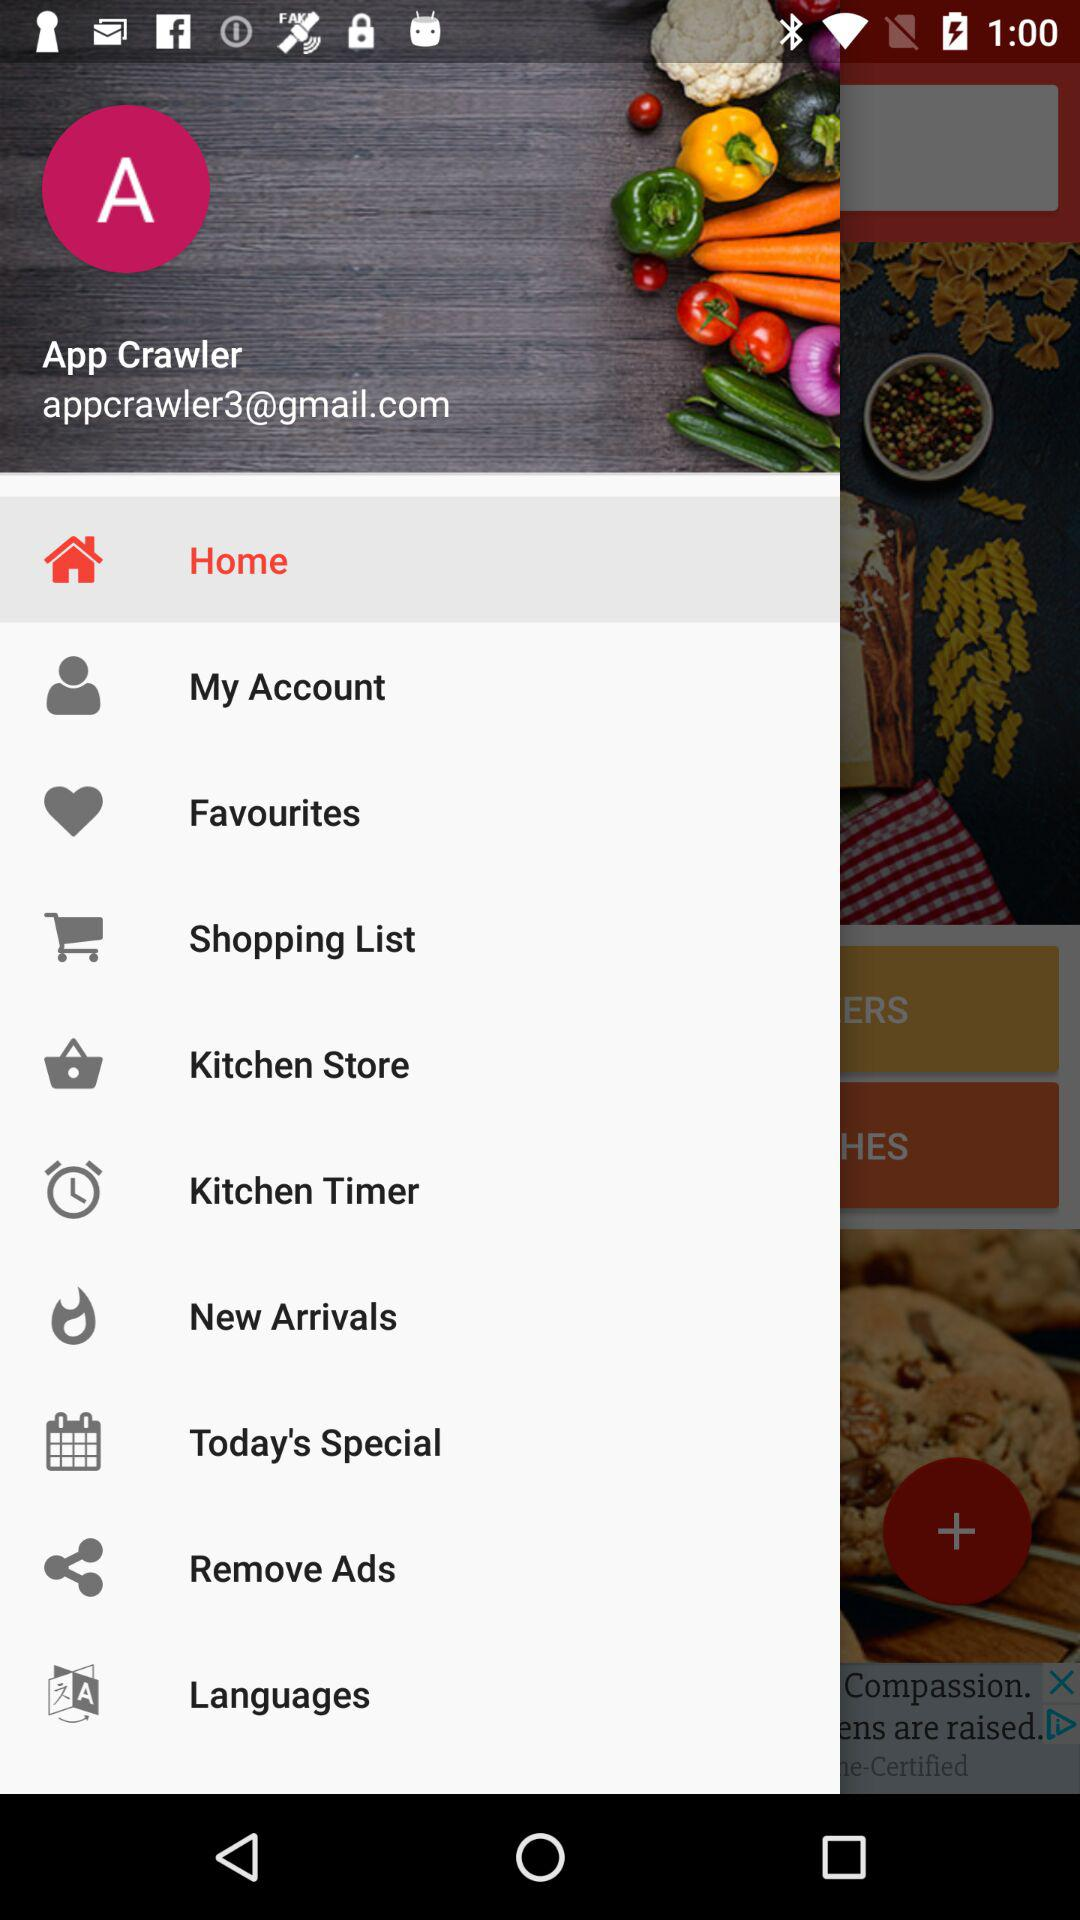What is the user name? The user name is App Crawler. 